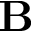<formula> <loc_0><loc_0><loc_500><loc_500>B</formula> 